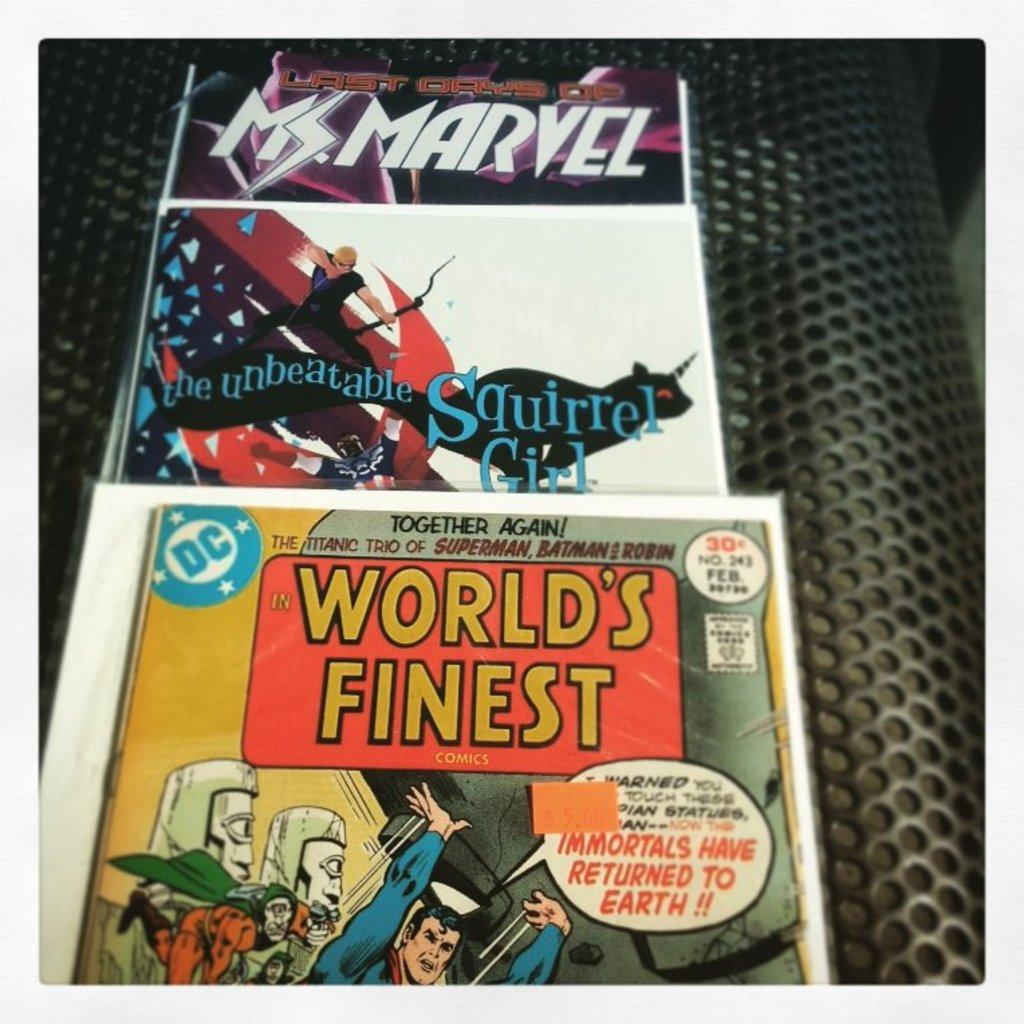<image>
Give a short and clear explanation of the subsequent image. several comic books like World's Finest on a mesh metal background 